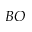Convert formula to latex. <formula><loc_0><loc_0><loc_500><loc_500>B O</formula> 